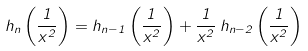<formula> <loc_0><loc_0><loc_500><loc_500>h _ { n } \left ( \frac { 1 } { x ^ { 2 } } \right ) = h _ { n - 1 } \left ( \frac { 1 } { x ^ { 2 } } \right ) + \frac { 1 } { x ^ { 2 } } \, h _ { n - 2 } \left ( \frac { 1 } { x ^ { 2 } } \right )</formula> 